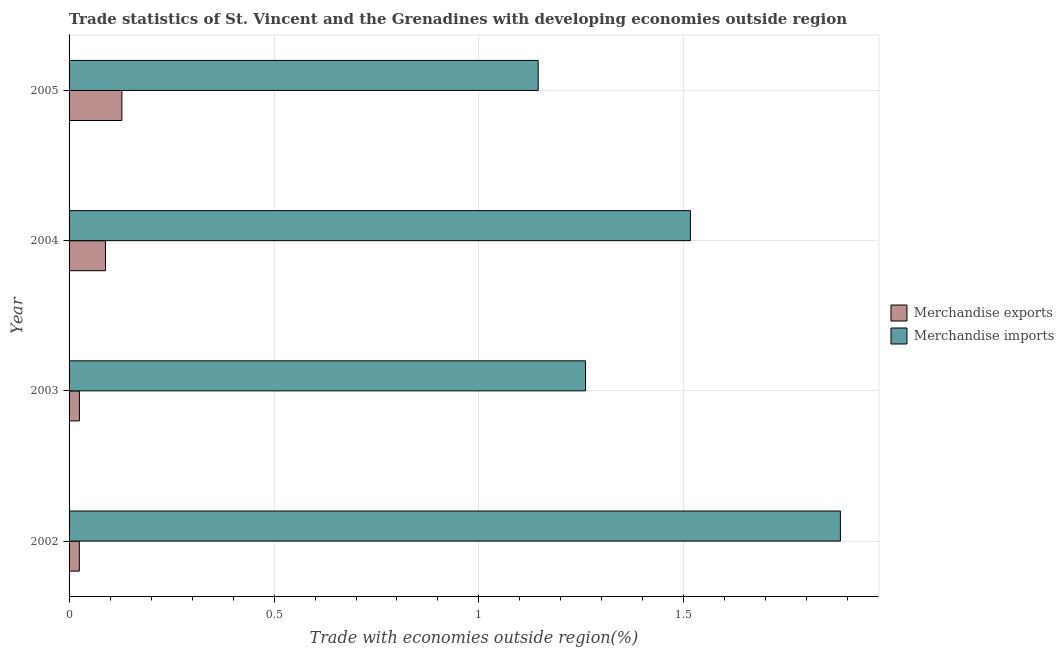How many different coloured bars are there?
Provide a short and direct response. 2. Are the number of bars per tick equal to the number of legend labels?
Provide a succinct answer. Yes. How many bars are there on the 1st tick from the top?
Your response must be concise. 2. How many bars are there on the 1st tick from the bottom?
Provide a succinct answer. 2. In how many cases, is the number of bars for a given year not equal to the number of legend labels?
Ensure brevity in your answer.  0. What is the merchandise imports in 2005?
Provide a succinct answer. 1.14. Across all years, what is the maximum merchandise imports?
Provide a short and direct response. 1.88. Across all years, what is the minimum merchandise exports?
Give a very brief answer. 0.03. In which year was the merchandise imports maximum?
Ensure brevity in your answer.  2002. What is the total merchandise exports in the graph?
Your response must be concise. 0.27. What is the difference between the merchandise imports in 2002 and that in 2003?
Make the answer very short. 0.62. What is the difference between the merchandise imports in 2004 and the merchandise exports in 2005?
Your response must be concise. 1.39. What is the average merchandise exports per year?
Provide a short and direct response. 0.07. In the year 2002, what is the difference between the merchandise imports and merchandise exports?
Your answer should be very brief. 1.86. In how many years, is the merchandise imports greater than 0.9 %?
Provide a short and direct response. 4. What is the ratio of the merchandise exports in 2002 to that in 2004?
Your answer should be very brief. 0.28. What is the difference between the highest and the second highest merchandise imports?
Provide a short and direct response. 0.37. Is the sum of the merchandise imports in 2002 and 2005 greater than the maximum merchandise exports across all years?
Offer a very short reply. Yes. What does the 2nd bar from the bottom in 2005 represents?
Keep it short and to the point. Merchandise imports. How many bars are there?
Offer a terse response. 8. Are the values on the major ticks of X-axis written in scientific E-notation?
Provide a succinct answer. No. Does the graph contain grids?
Your answer should be very brief. Yes. Where does the legend appear in the graph?
Provide a short and direct response. Center right. How many legend labels are there?
Your answer should be compact. 2. What is the title of the graph?
Make the answer very short. Trade statistics of St. Vincent and the Grenadines with developing economies outside region. Does "Under five" appear as one of the legend labels in the graph?
Your answer should be very brief. No. What is the label or title of the X-axis?
Provide a succinct answer. Trade with economies outside region(%). What is the label or title of the Y-axis?
Make the answer very short. Year. What is the Trade with economies outside region(%) of Merchandise exports in 2002?
Keep it short and to the point. 0.03. What is the Trade with economies outside region(%) of Merchandise imports in 2002?
Your response must be concise. 1.88. What is the Trade with economies outside region(%) of Merchandise exports in 2003?
Provide a short and direct response. 0.03. What is the Trade with economies outside region(%) of Merchandise imports in 2003?
Ensure brevity in your answer.  1.26. What is the Trade with economies outside region(%) of Merchandise exports in 2004?
Your response must be concise. 0.09. What is the Trade with economies outside region(%) of Merchandise imports in 2004?
Your response must be concise. 1.52. What is the Trade with economies outside region(%) in Merchandise exports in 2005?
Your answer should be very brief. 0.13. What is the Trade with economies outside region(%) in Merchandise imports in 2005?
Your answer should be very brief. 1.14. Across all years, what is the maximum Trade with economies outside region(%) in Merchandise exports?
Make the answer very short. 0.13. Across all years, what is the maximum Trade with economies outside region(%) of Merchandise imports?
Your answer should be compact. 1.88. Across all years, what is the minimum Trade with economies outside region(%) in Merchandise exports?
Offer a terse response. 0.03. Across all years, what is the minimum Trade with economies outside region(%) in Merchandise imports?
Your answer should be compact. 1.14. What is the total Trade with economies outside region(%) of Merchandise exports in the graph?
Ensure brevity in your answer.  0.27. What is the total Trade with economies outside region(%) in Merchandise imports in the graph?
Give a very brief answer. 5.8. What is the difference between the Trade with economies outside region(%) of Merchandise exports in 2002 and that in 2003?
Make the answer very short. -0. What is the difference between the Trade with economies outside region(%) of Merchandise imports in 2002 and that in 2003?
Provide a succinct answer. 0.62. What is the difference between the Trade with economies outside region(%) of Merchandise exports in 2002 and that in 2004?
Give a very brief answer. -0.06. What is the difference between the Trade with economies outside region(%) in Merchandise imports in 2002 and that in 2004?
Your answer should be compact. 0.37. What is the difference between the Trade with economies outside region(%) in Merchandise exports in 2002 and that in 2005?
Your answer should be very brief. -0.1. What is the difference between the Trade with economies outside region(%) in Merchandise imports in 2002 and that in 2005?
Your answer should be very brief. 0.74. What is the difference between the Trade with economies outside region(%) of Merchandise exports in 2003 and that in 2004?
Ensure brevity in your answer.  -0.06. What is the difference between the Trade with economies outside region(%) in Merchandise imports in 2003 and that in 2004?
Make the answer very short. -0.26. What is the difference between the Trade with economies outside region(%) of Merchandise exports in 2003 and that in 2005?
Keep it short and to the point. -0.1. What is the difference between the Trade with economies outside region(%) in Merchandise imports in 2003 and that in 2005?
Your response must be concise. 0.12. What is the difference between the Trade with economies outside region(%) of Merchandise exports in 2004 and that in 2005?
Offer a very short reply. -0.04. What is the difference between the Trade with economies outside region(%) in Merchandise imports in 2004 and that in 2005?
Your answer should be very brief. 0.37. What is the difference between the Trade with economies outside region(%) of Merchandise exports in 2002 and the Trade with economies outside region(%) of Merchandise imports in 2003?
Your answer should be very brief. -1.24. What is the difference between the Trade with economies outside region(%) of Merchandise exports in 2002 and the Trade with economies outside region(%) of Merchandise imports in 2004?
Ensure brevity in your answer.  -1.49. What is the difference between the Trade with economies outside region(%) of Merchandise exports in 2002 and the Trade with economies outside region(%) of Merchandise imports in 2005?
Offer a terse response. -1.12. What is the difference between the Trade with economies outside region(%) of Merchandise exports in 2003 and the Trade with economies outside region(%) of Merchandise imports in 2004?
Give a very brief answer. -1.49. What is the difference between the Trade with economies outside region(%) in Merchandise exports in 2003 and the Trade with economies outside region(%) in Merchandise imports in 2005?
Provide a succinct answer. -1.12. What is the difference between the Trade with economies outside region(%) in Merchandise exports in 2004 and the Trade with economies outside region(%) in Merchandise imports in 2005?
Offer a terse response. -1.06. What is the average Trade with economies outside region(%) in Merchandise exports per year?
Ensure brevity in your answer.  0.07. What is the average Trade with economies outside region(%) in Merchandise imports per year?
Your answer should be very brief. 1.45. In the year 2002, what is the difference between the Trade with economies outside region(%) of Merchandise exports and Trade with economies outside region(%) of Merchandise imports?
Give a very brief answer. -1.86. In the year 2003, what is the difference between the Trade with economies outside region(%) in Merchandise exports and Trade with economies outside region(%) in Merchandise imports?
Your answer should be very brief. -1.23. In the year 2004, what is the difference between the Trade with economies outside region(%) of Merchandise exports and Trade with economies outside region(%) of Merchandise imports?
Your answer should be very brief. -1.43. In the year 2005, what is the difference between the Trade with economies outside region(%) in Merchandise exports and Trade with economies outside region(%) in Merchandise imports?
Offer a terse response. -1.02. What is the ratio of the Trade with economies outside region(%) in Merchandise exports in 2002 to that in 2003?
Offer a very short reply. 0.99. What is the ratio of the Trade with economies outside region(%) in Merchandise imports in 2002 to that in 2003?
Your answer should be very brief. 1.49. What is the ratio of the Trade with economies outside region(%) of Merchandise exports in 2002 to that in 2004?
Provide a short and direct response. 0.28. What is the ratio of the Trade with economies outside region(%) of Merchandise imports in 2002 to that in 2004?
Your answer should be compact. 1.24. What is the ratio of the Trade with economies outside region(%) in Merchandise exports in 2002 to that in 2005?
Offer a very short reply. 0.19. What is the ratio of the Trade with economies outside region(%) in Merchandise imports in 2002 to that in 2005?
Your response must be concise. 1.64. What is the ratio of the Trade with economies outside region(%) in Merchandise exports in 2003 to that in 2004?
Offer a terse response. 0.28. What is the ratio of the Trade with economies outside region(%) of Merchandise imports in 2003 to that in 2004?
Your answer should be compact. 0.83. What is the ratio of the Trade with economies outside region(%) of Merchandise exports in 2003 to that in 2005?
Offer a terse response. 0.2. What is the ratio of the Trade with economies outside region(%) of Merchandise imports in 2003 to that in 2005?
Keep it short and to the point. 1.1. What is the ratio of the Trade with economies outside region(%) in Merchandise exports in 2004 to that in 2005?
Your answer should be very brief. 0.69. What is the ratio of the Trade with economies outside region(%) of Merchandise imports in 2004 to that in 2005?
Your answer should be very brief. 1.32. What is the difference between the highest and the second highest Trade with economies outside region(%) in Merchandise exports?
Offer a very short reply. 0.04. What is the difference between the highest and the second highest Trade with economies outside region(%) in Merchandise imports?
Your answer should be compact. 0.37. What is the difference between the highest and the lowest Trade with economies outside region(%) in Merchandise exports?
Your answer should be very brief. 0.1. What is the difference between the highest and the lowest Trade with economies outside region(%) in Merchandise imports?
Offer a terse response. 0.74. 